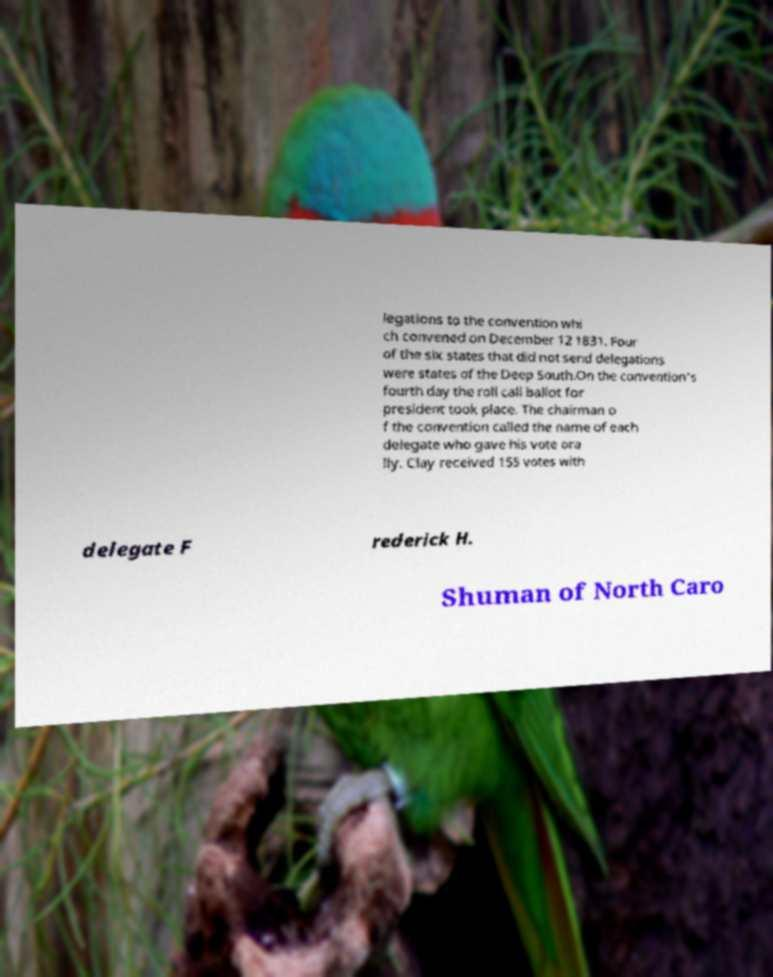Can you read and provide the text displayed in the image?This photo seems to have some interesting text. Can you extract and type it out for me? legations to the convention whi ch convened on December 12 1831. Four of the six states that did not send delegations were states of the Deep South.On the convention's fourth day the roll call ballot for president took place. The chairman o f the convention called the name of each delegate who gave his vote ora lly. Clay received 155 votes with delegate F rederick H. Shuman of North Caro 